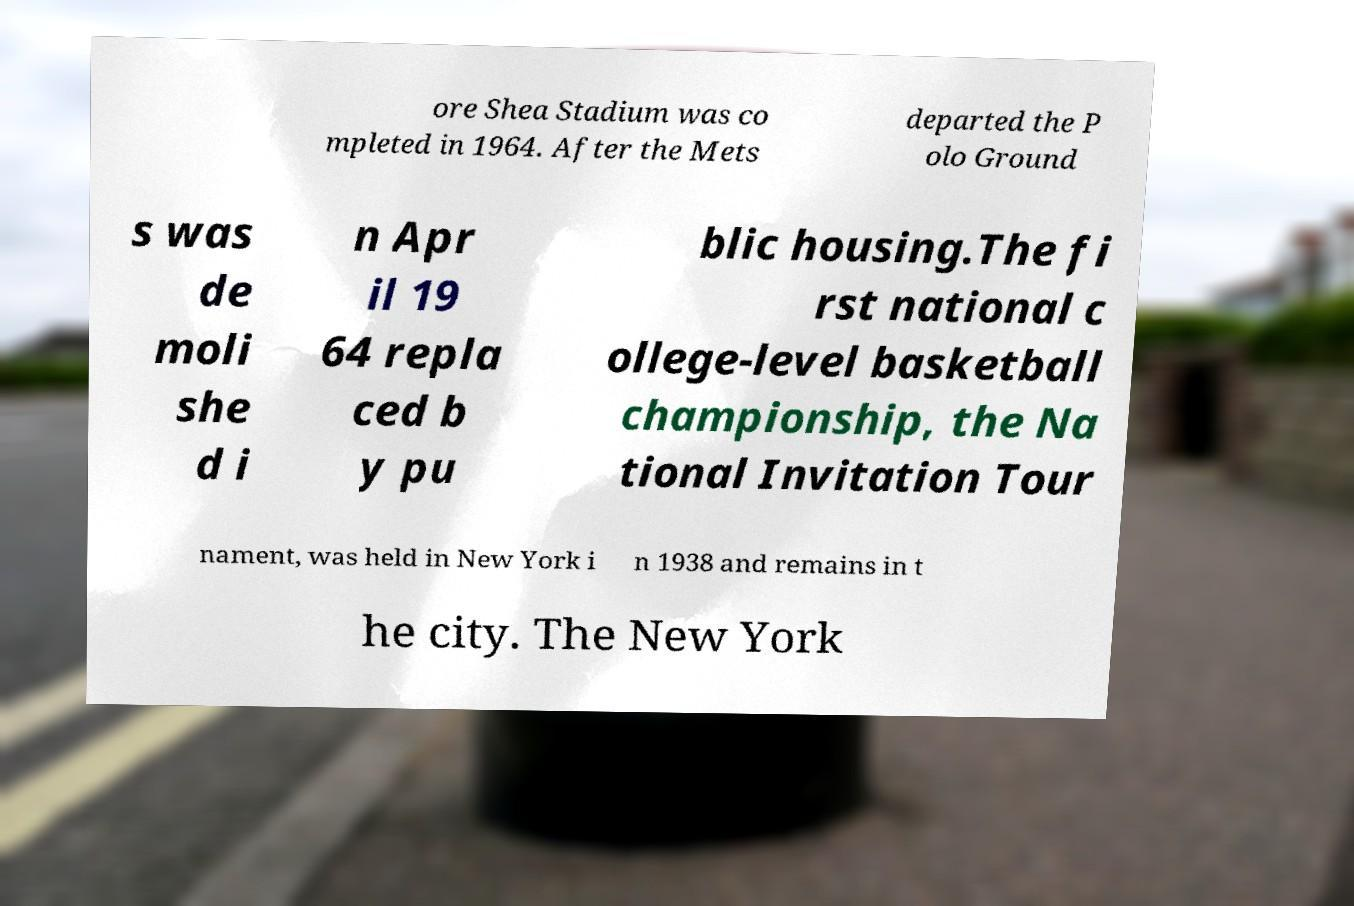Could you extract and type out the text from this image? ore Shea Stadium was co mpleted in 1964. After the Mets departed the P olo Ground s was de moli she d i n Apr il 19 64 repla ced b y pu blic housing.The fi rst national c ollege-level basketball championship, the Na tional Invitation Tour nament, was held in New York i n 1938 and remains in t he city. The New York 